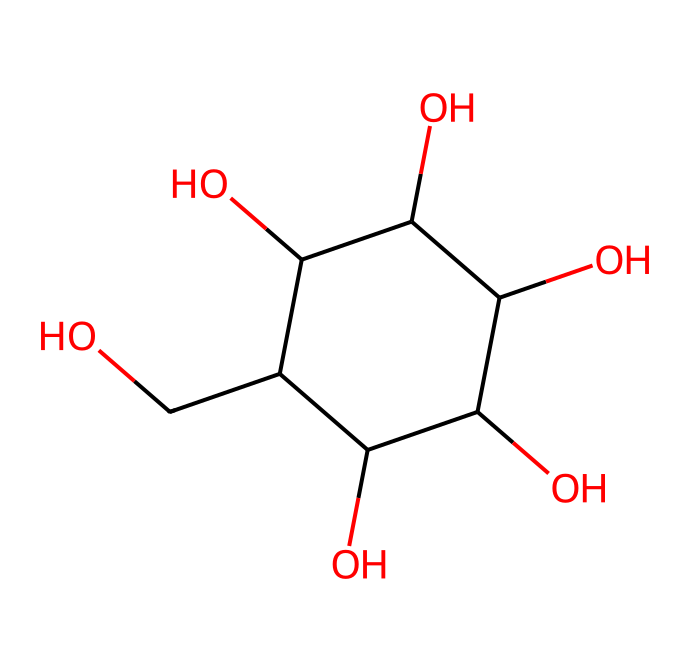How many carbon atoms are in the glucose molecule? The provided SMILES representation indicates the structure is that of glucose. By interpreting the chemical structure, we can count the number of carbon atoms represented in the string, specifically the 'C' characters. In this SMILES, there are six carbon atoms in total.
Answer: six What is the name of this chemical? This chemical’s structure corresponds to the well-known sugar glucose, which is commonly found in energy drinks. The specific arrangement of atoms and bonds in the SMILES confirms this identification.
Answer: glucose How many hydroxyl (-OH) groups are present in the molecule? By examining the SMILES representation, we can identify the hydroxyl groups by counting the occurrences of 'O' linked to a hydrogen atom (i.e., -OH functionality). In this case, there are five hydroxyl groups visible in the structure.
Answer: five What type of carbohydrate does this structure represent? Glucose is classified as a monosaccharide, which is the simplest form of carbohydrate. Its structure represents a single sugar unit, distinguishing it from oligosaccharides or polysaccharides.
Answer: monosaccharide How does the molecular structure relate to its sweet taste? The molecular structure of glucose includes the arrangement of hydroxyl groups and carbons that engage in sweetness perception when tasting. This specific architecture contributes to its sweet flavor profile, which is an attribute of simple sugars.
Answer: sweetness What role do carbohydrates like glucose play in energy drinks? Carbohydrates such as glucose serve as a quick source of energy. They are rapidly metabolized by the body, providing the necessary fuel for increased physical or cognitive activities during long meetings.
Answer: energy source 